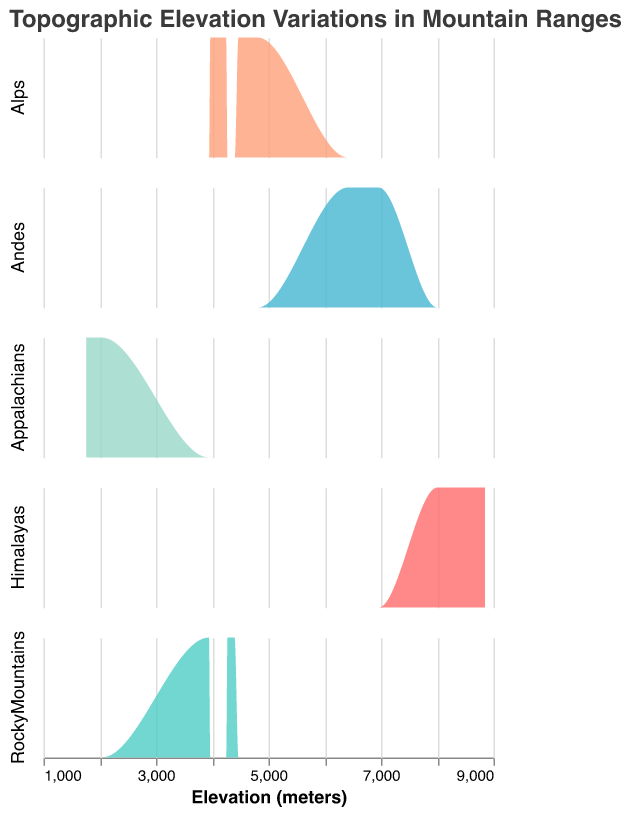What's the title of the plot? The title is typically displayed at the top of the figure and provides a summary of what the figure represents. In this case, the title is "Topographic Elevation Variations in Mountain Ranges".
Answer: Topographic Elevation Variations in Mountain Ranges What is the highest recorded elevation in the Himalayas? In the subplot for the Himalayas, the highest point on the x-axis represents the highest recorded elevation. The value at this point is 8848 meters.
Answer: 8848 meters Which color represents the Alps? The color of each mountain range can be determined by looking at the plot. The Alps are represented by a specific color indicated in the plot. For the Alps, this color is a light salmon-like color.
Answer: Light salmon color Which mountain range has the lowest maximum elevation? The subplot for each mountain range shows the variation in elevations. By comparing the highest values on the x-axes across the subplots, the Appalachians have the lowest maximum elevation of 2037 meters.
Answer: Appalachians What is the range of elevations in the Andes? The range of elevations can be found by identifying the minimum and maximum points in the subplot for the Andes. The minimum elevation is 6410, and the maximum is 6961, so the range is 6961 - 6410 = 551 meters.
Answer: 551 meters How many data points are there for the Rocky Mountains? The number of data points is represented by the peaks in the density plot. By counting the individual peaks in the Rocky Mountains subplot, we find there are four data points.
Answer: 4 Compare the maximum elevation of the Andes and the Alps. To compare maximum elevations, we look for the highest points on the x-axis of the Andes and Alps subplots. The Andes have a maximum elevation of 6961 meters while the Alps have a maximum elevation of 4810 meters. Therefore, the Andes have a higher maximum elevation.
Answer: Andes Which mountain range shows a wider spread in elevation values? A wider spread in elevation values means a greater difference between the minimum and maximum elevations. By comparing the spreads in the subplots, the Himalayas show the widest spread ranging from 8000 to 8848 meters, a spread of 848 meters.
Answer: Himalayas In which range does the Rocky Mountains elevation primarily fall? The primary range of elevations can be identified by the range where the majority of the density is concentrated. For the Rocky Mountains, most of the elevations fall between 3900 and 4400 meters.
Answer: 3900 to 4400 meters Is there any overlap in elevation between the Alps and the Andes? To see if there is any overlap, we compare the elevation ranges of the Alps (3964 - 4810 meters) and the Andes (6410 - 6961 meters). There is no overlap as the ranges do not intersect.
Answer: No 